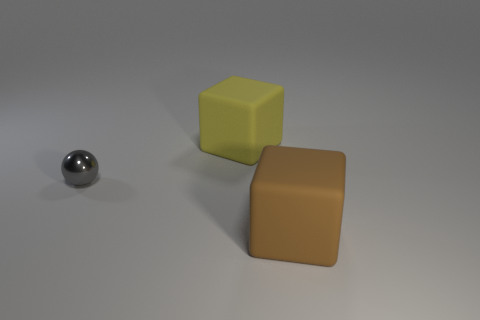How many other things are the same size as the metal object?
Your answer should be compact. 0. What color is the large thing that is behind the brown rubber object?
Offer a very short reply. Yellow. Do the object to the right of the big yellow rubber cube and the sphere have the same material?
Offer a terse response. No. How many objects are to the right of the yellow object and behind the metal thing?
Your response must be concise. 0. There is a block behind the big brown rubber object that is to the right of the object that is behind the small ball; what color is it?
Provide a succinct answer. Yellow. How many other objects are there of the same shape as the small gray object?
Offer a very short reply. 0. Are there any big yellow rubber objects that are in front of the large thing in front of the yellow matte cube?
Offer a terse response. No. What number of matte things are red things or yellow blocks?
Your response must be concise. 1. There is a thing that is to the left of the brown matte thing and in front of the yellow rubber cube; what material is it made of?
Ensure brevity in your answer.  Metal. Are there any yellow objects that are right of the tiny gray ball that is behind the matte block that is in front of the tiny gray metallic object?
Your answer should be very brief. Yes. 